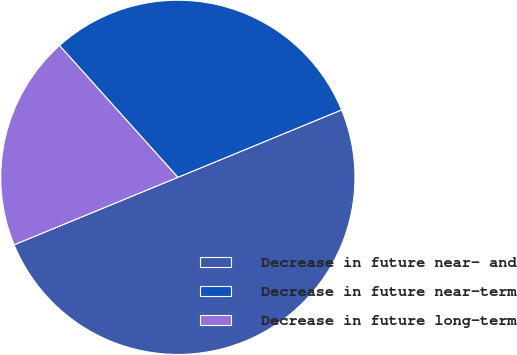Convert chart. <chart><loc_0><loc_0><loc_500><loc_500><pie_chart><fcel>Decrease in future near- and<fcel>Decrease in future near-term<fcel>Decrease in future long-term<nl><fcel>50.0%<fcel>30.43%<fcel>19.57%<nl></chart> 